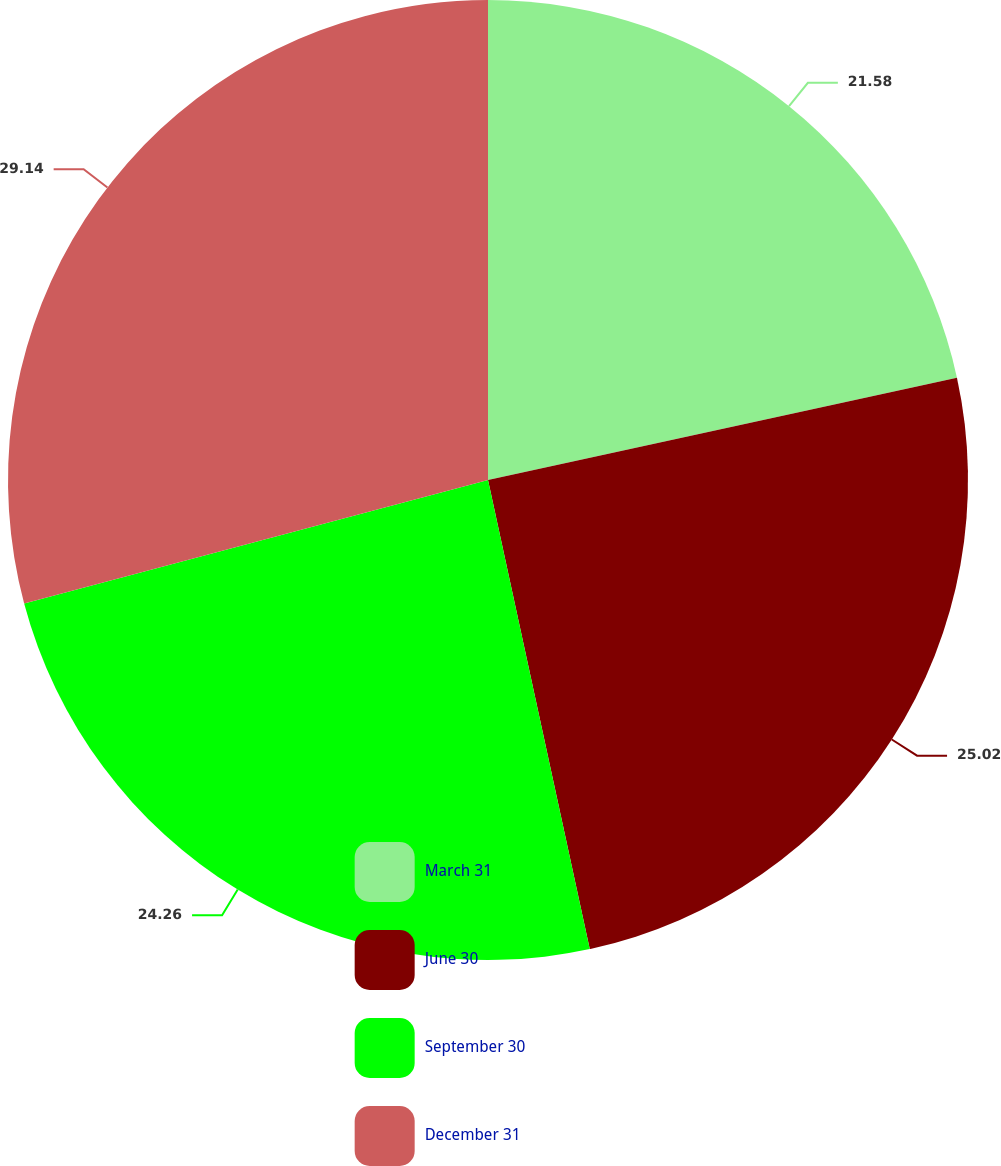Convert chart to OTSL. <chart><loc_0><loc_0><loc_500><loc_500><pie_chart><fcel>March 31<fcel>June 30<fcel>September 30<fcel>December 31<nl><fcel>21.58%<fcel>25.02%<fcel>24.26%<fcel>29.14%<nl></chart> 